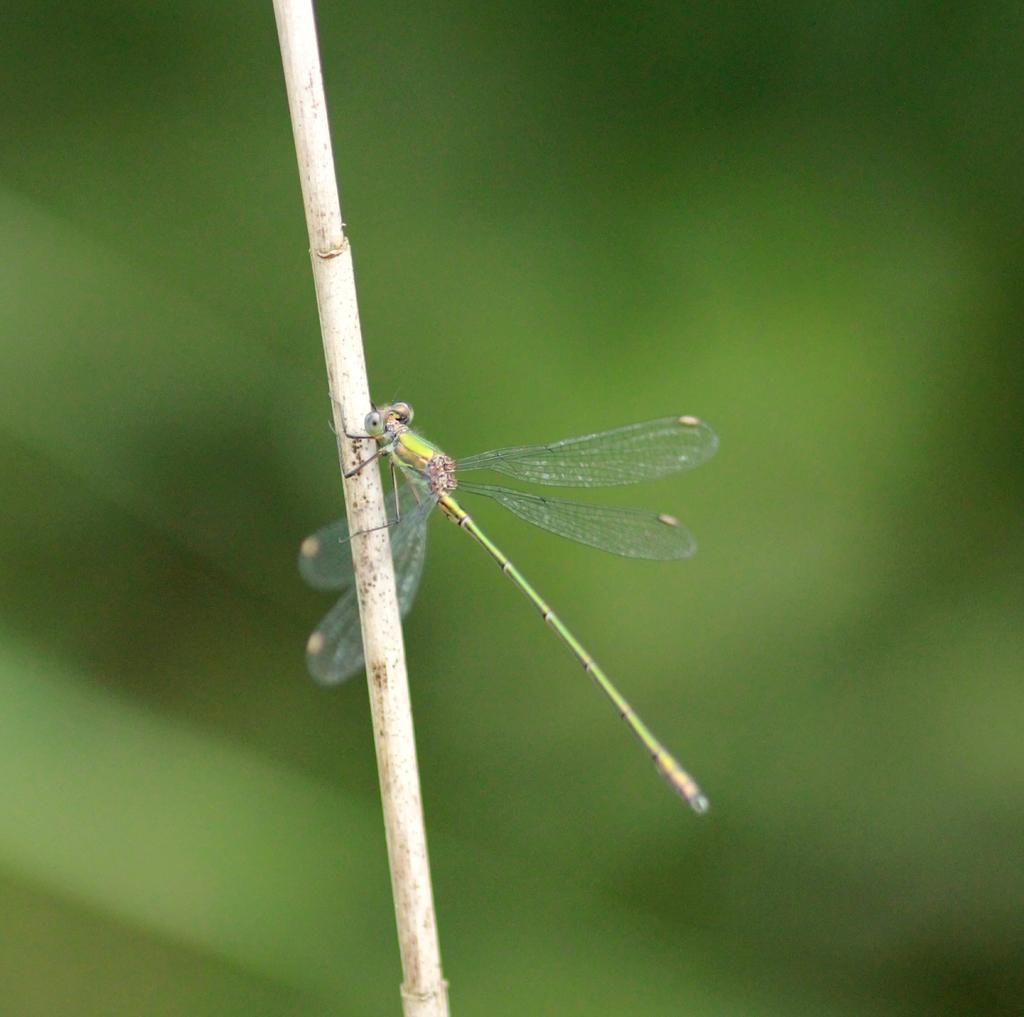How would you summarize this image in a sentence or two? In this image there is a dragonfly, in the background it is blurry. 